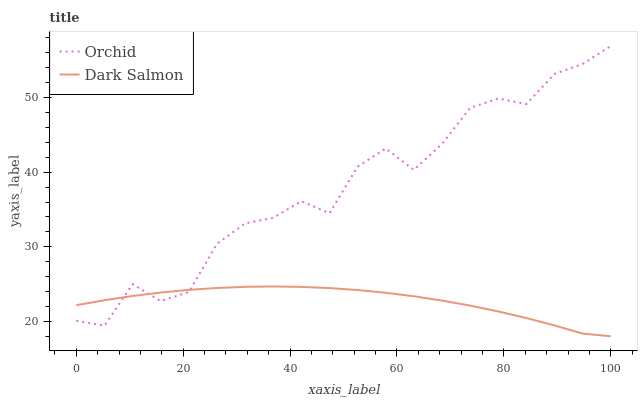Does Dark Salmon have the minimum area under the curve?
Answer yes or no. Yes. Does Orchid have the maximum area under the curve?
Answer yes or no. Yes. Does Orchid have the minimum area under the curve?
Answer yes or no. No. Is Dark Salmon the smoothest?
Answer yes or no. Yes. Is Orchid the roughest?
Answer yes or no. Yes. Is Orchid the smoothest?
Answer yes or no. No. Does Dark Salmon have the lowest value?
Answer yes or no. Yes. Does Orchid have the lowest value?
Answer yes or no. No. Does Orchid have the highest value?
Answer yes or no. Yes. Does Orchid intersect Dark Salmon?
Answer yes or no. Yes. Is Orchid less than Dark Salmon?
Answer yes or no. No. Is Orchid greater than Dark Salmon?
Answer yes or no. No. 